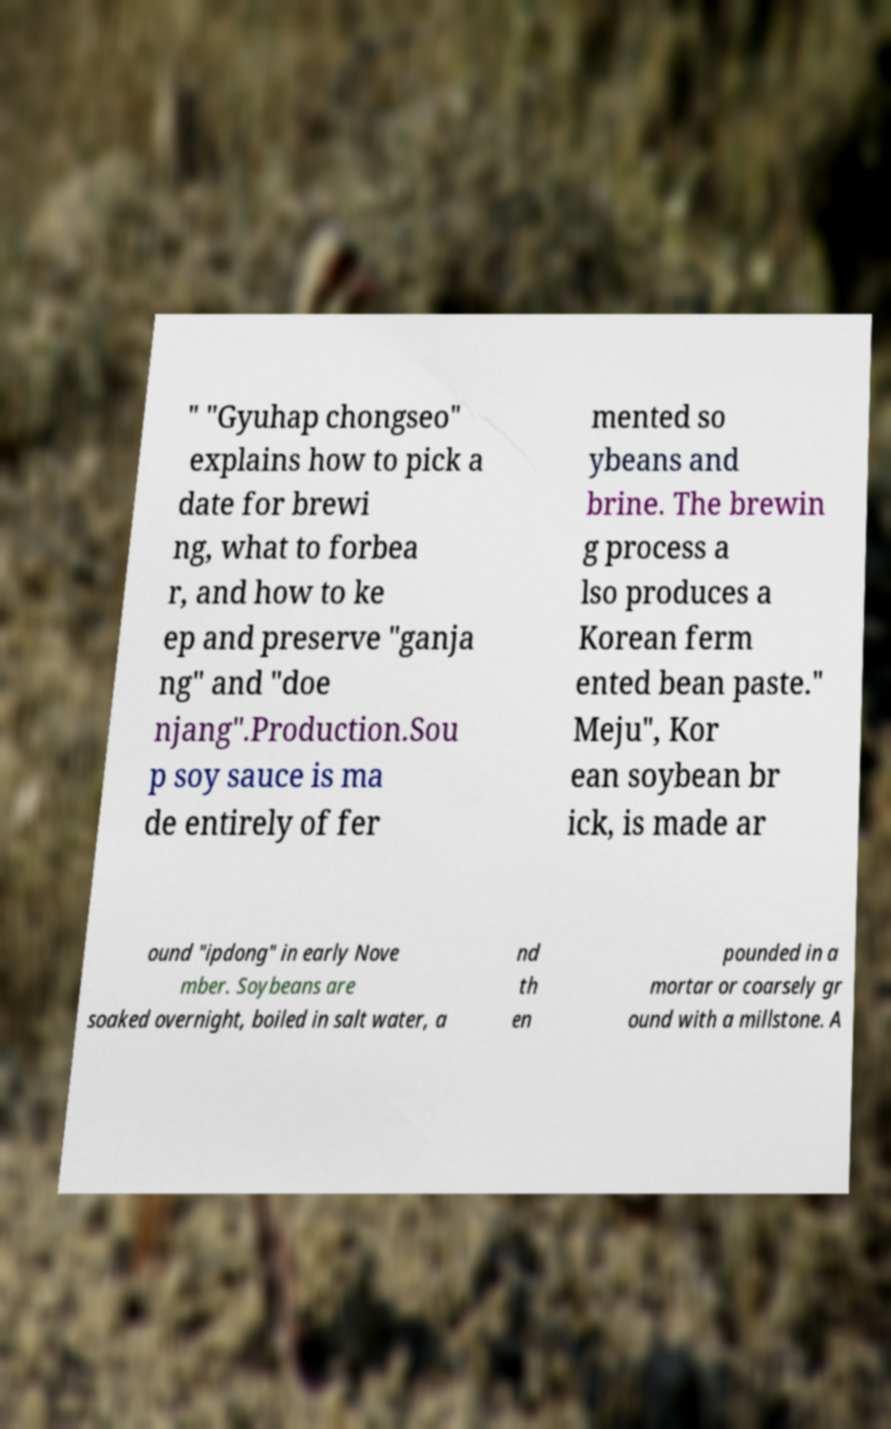Could you assist in decoding the text presented in this image and type it out clearly? " "Gyuhap chongseo" explains how to pick a date for brewi ng, what to forbea r, and how to ke ep and preserve "ganja ng" and "doe njang".Production.Sou p soy sauce is ma de entirely of fer mented so ybeans and brine. The brewin g process a lso produces a Korean ferm ented bean paste." Meju", Kor ean soybean br ick, is made ar ound "ipdong" in early Nove mber. Soybeans are soaked overnight, boiled in salt water, a nd th en pounded in a mortar or coarsely gr ound with a millstone. A 